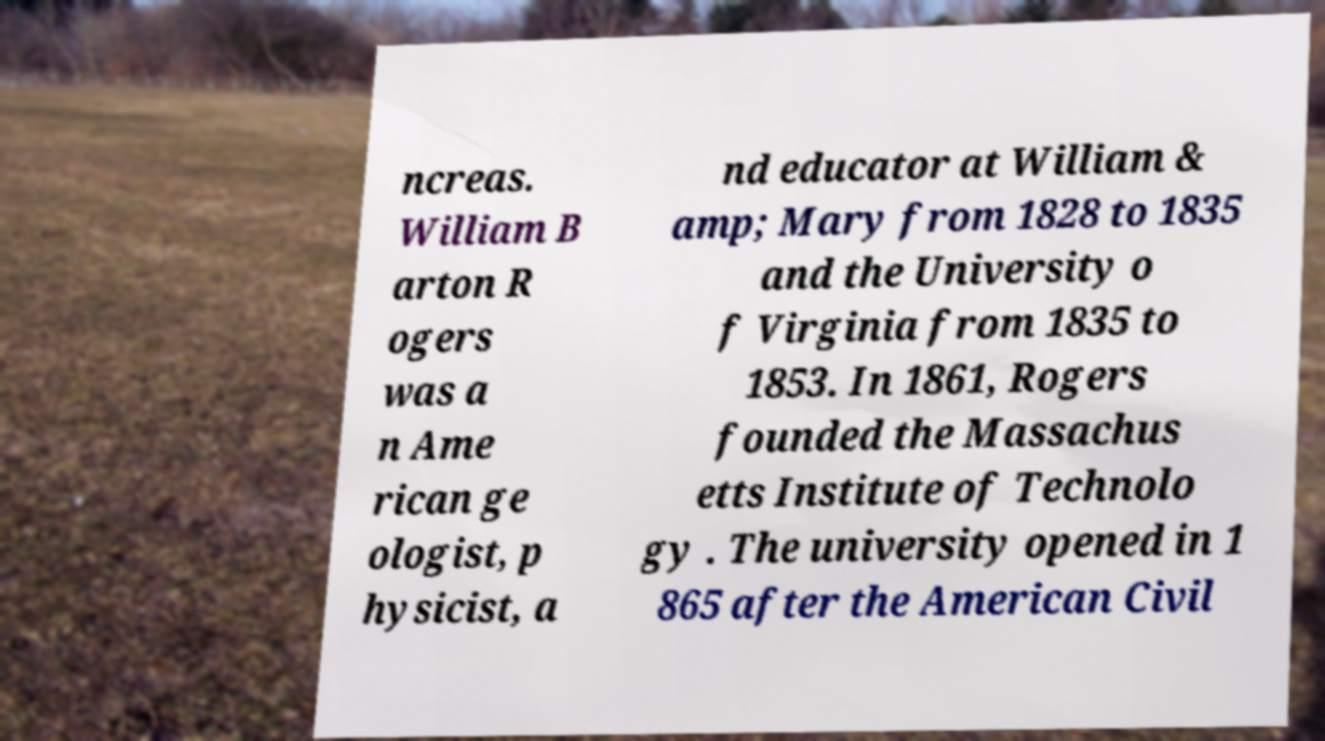For documentation purposes, I need the text within this image transcribed. Could you provide that? ncreas. William B arton R ogers was a n Ame rican ge ologist, p hysicist, a nd educator at William & amp; Mary from 1828 to 1835 and the University o f Virginia from 1835 to 1853. In 1861, Rogers founded the Massachus etts Institute of Technolo gy . The university opened in 1 865 after the American Civil 